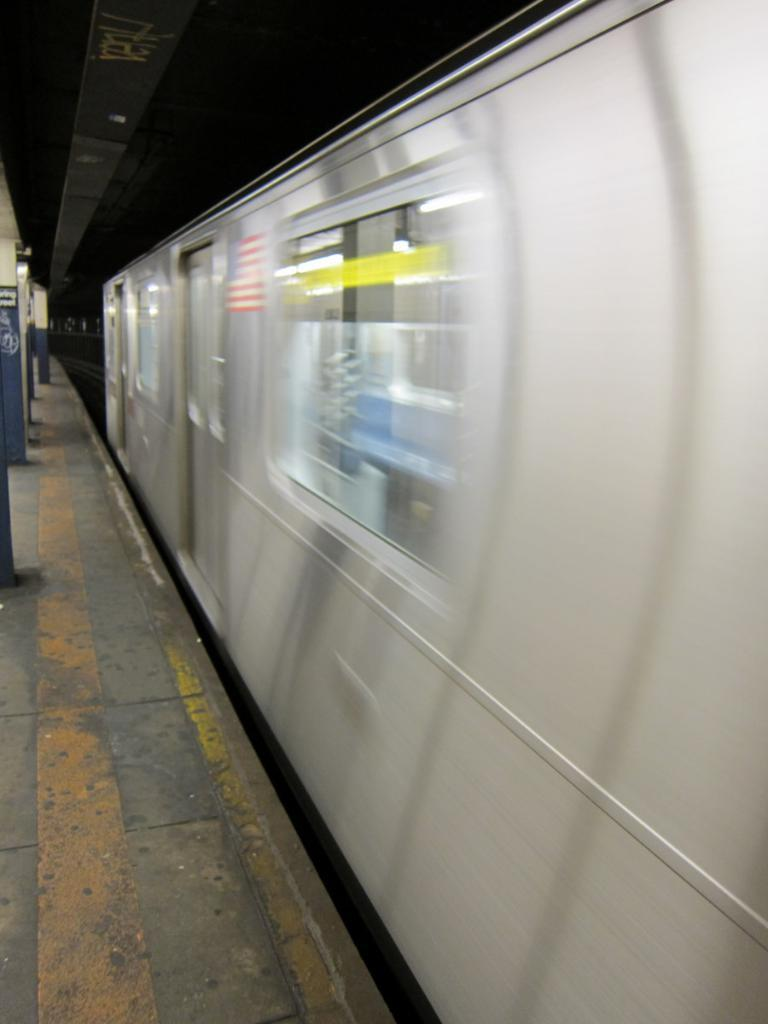What is the main subject of the image? The main subject of the image is a train. What is the train doing in the image? The train is moving in the image. What color is the train? The train is white in color. What can be seen on the left side of the image? There is a platform on the left side of the image. What type of flag is being waved by the passengers on the train? There is no flag visible in the image, nor are there any passengers waving a flag. 